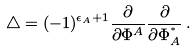<formula> <loc_0><loc_0><loc_500><loc_500>\bigtriangleup = ( - 1 ) ^ { \epsilon _ { A } + 1 } \frac { \partial } { \partial \Phi ^ { A } } \frac { \partial } { \partial \Phi _ { A } ^ { ^ { * } } } \, .</formula> 